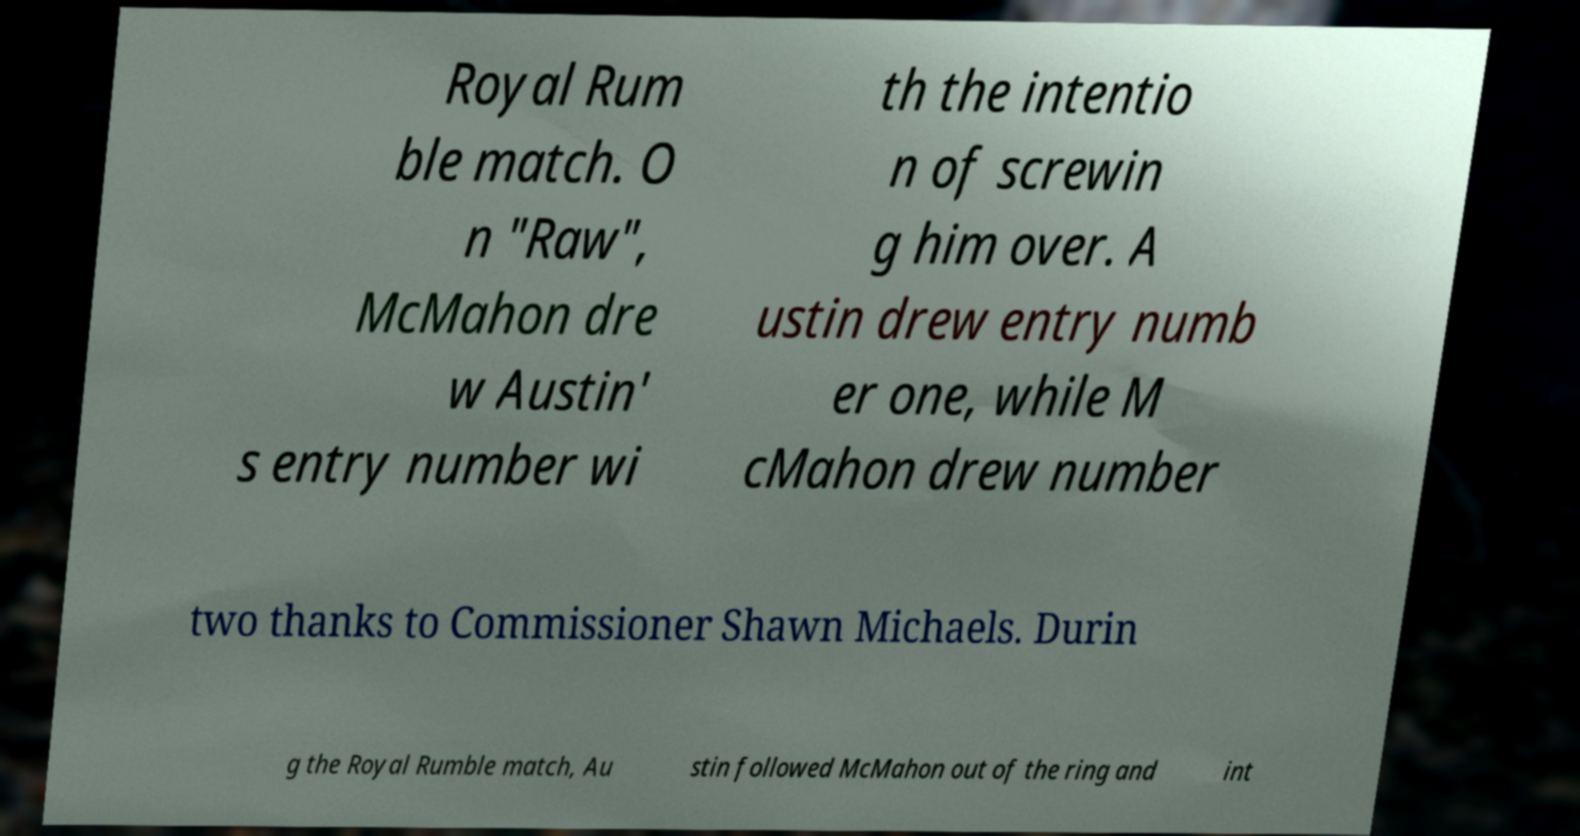Could you extract and type out the text from this image? Royal Rum ble match. O n "Raw", McMahon dre w Austin' s entry number wi th the intentio n of screwin g him over. A ustin drew entry numb er one, while M cMahon drew number two thanks to Commissioner Shawn Michaels. Durin g the Royal Rumble match, Au stin followed McMahon out of the ring and int 